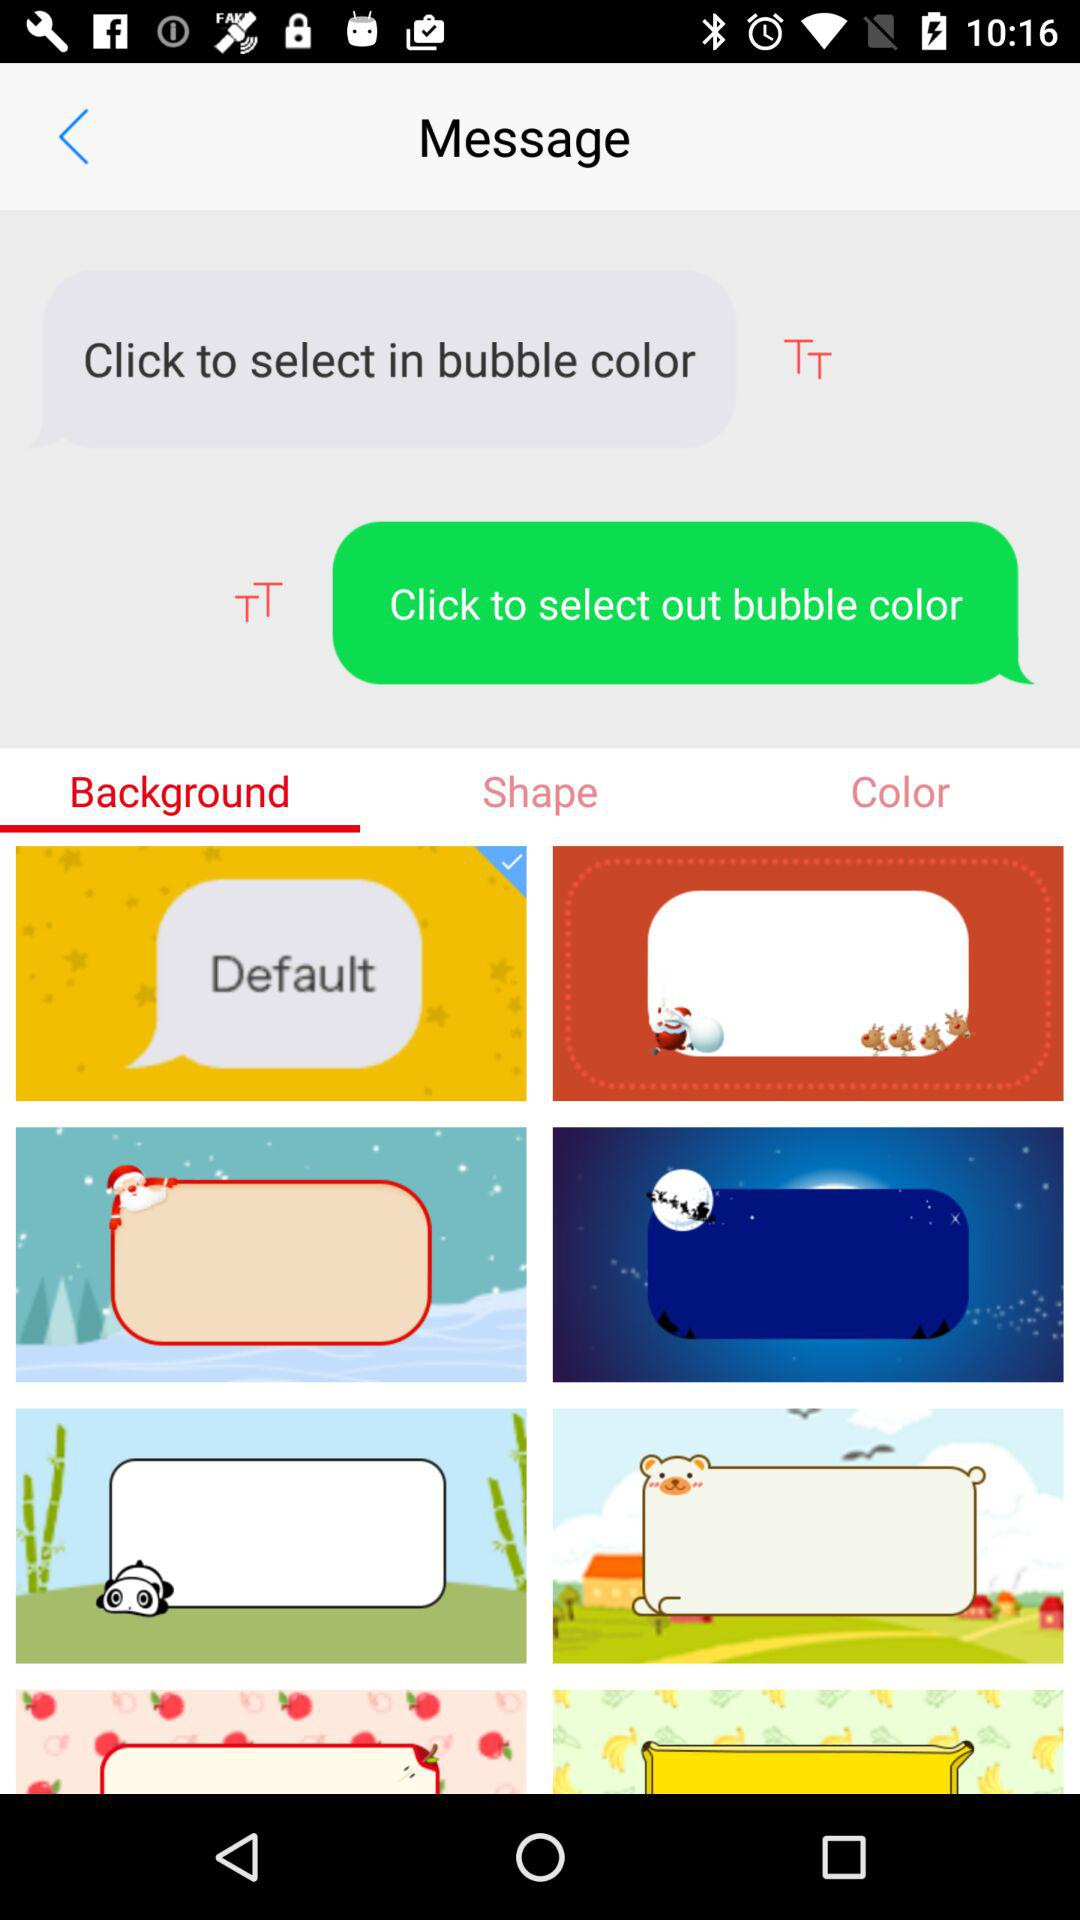Which tab is selected? The selected tab is "Background". 